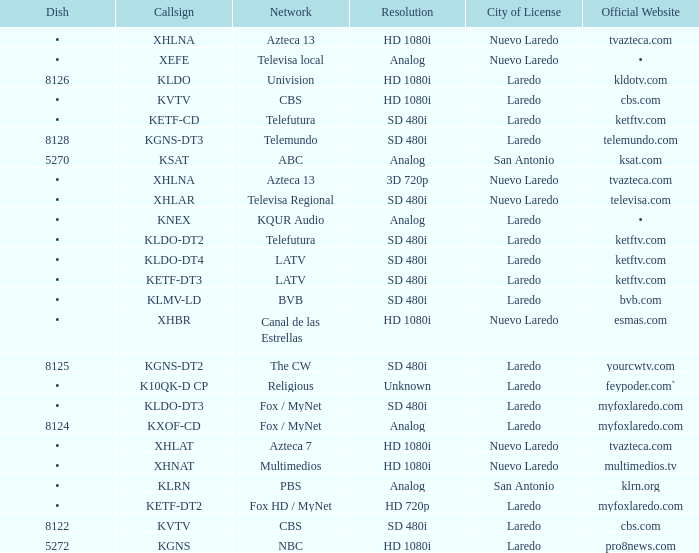Name the city of license with resolution of sd 480i and official website of telemundo.com Laredo. 